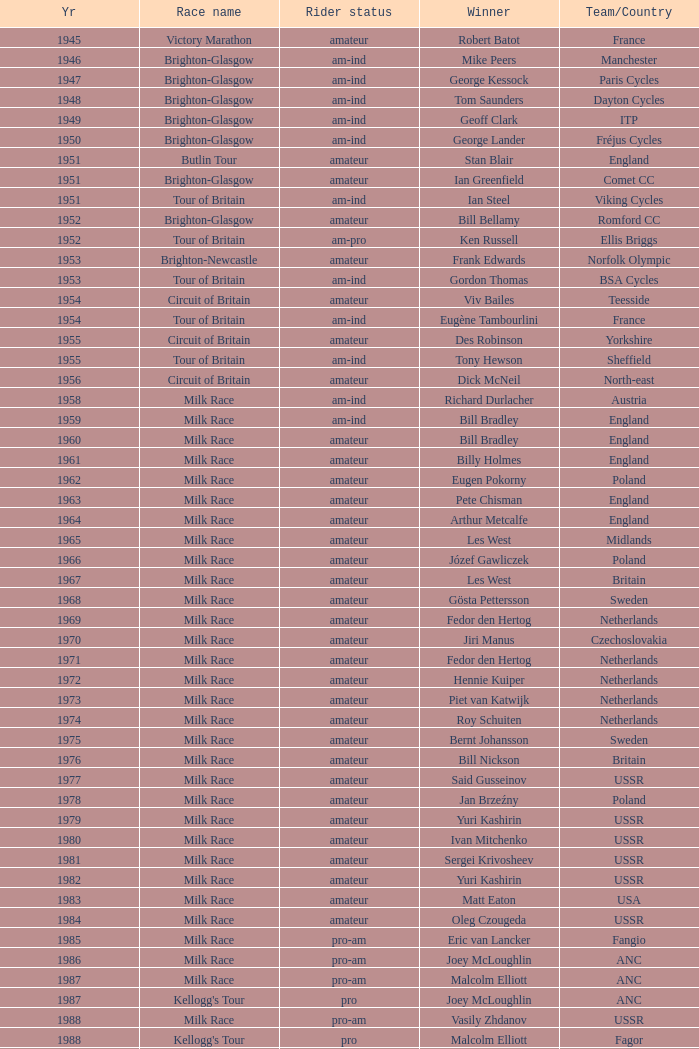What ream played later than 1958 in the kellogg's tour? ANC, Fagor, Z-Peugeot, Weinnmann-SMM, Motorola, Motorola, Motorola, Lampre. 